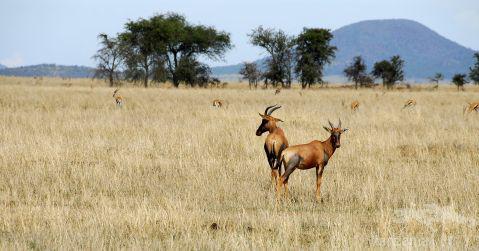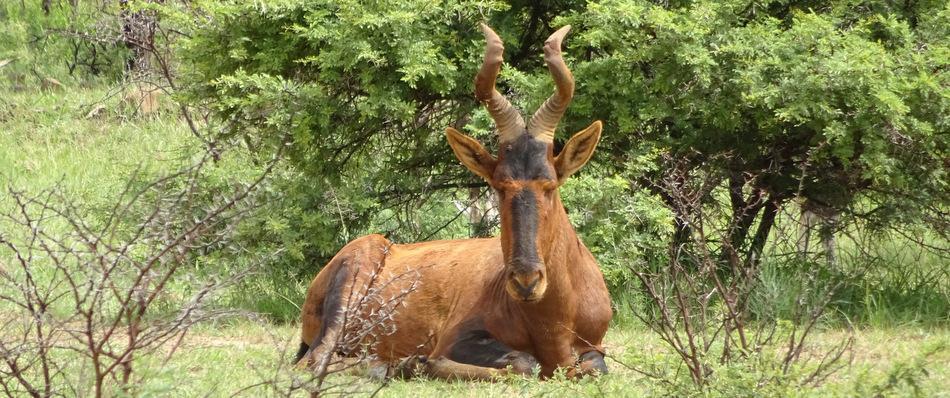The first image is the image on the left, the second image is the image on the right. Evaluate the accuracy of this statement regarding the images: "Two brown horned animals positioned sideways toward the same direction are alone in a wilderness area, at least one of them showing its tail.". Is it true? Answer yes or no. No. The first image is the image on the left, the second image is the image on the right. For the images displayed, is the sentence "Two antelopes are facing right." factually correct? Answer yes or no. No. 